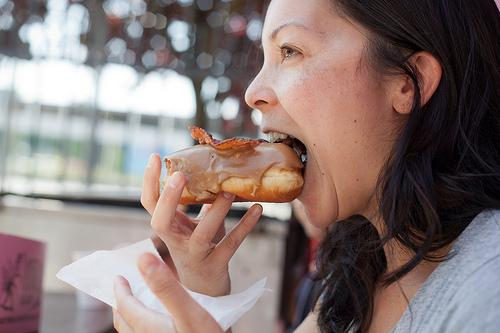List three facial features of the woman in the image. The woman has a brown left eye, a nose, and a left ear. In the image, mention an object that appears to be on a table. There is a cup on the table. Analyze the interaction between the woman and the donut in the context of the image. The woman is actively engaged in eating the donut, as she holds it to her mouth and appears to be biting it. The donut has a significant presence in the scene, with details like the brown icing and chocolate chips described. What is the woman wearing, and what is the color of her hair? The woman is wearing a gray shirt, and her hair is black. Describe the background and the setting of the scene depicted in the image. The scene is set outdoors with lights in the distance, and the background is slightly blurred. There is a purple sign on a window, and a red and black object in the background. Provide an estimation for the total number of objects mentioned in the image. There are approximately 39 different objects mentioned within the image. Assess the emotion or sentiment conveyed by the image. The image conveys a feeling of enjoyment or indulgence, as the woman is eating a designer donut. Determine the quality of the given image based on the mentioned details in the image. The image seems to be of decent quality, as the image information provides a substantial number of details about various objects and features within the scene. Identify the color of the donut's icing and the activity the woman is doing in the image. The icing on the donut is brown, and the woman is biting or eating the donut. What is the woman holding in her hand besides the donut, and what color is it? The woman is holding a white napkin in her hand. Identify the woman's eye color. Brown What color is the woman's hair? Black What is the color of the item in the background? Red and black Determine if the image is indoors or outdoors. Outdoors Categorize the woman's hair color and length. Black and long Analyze the image and create a descriptive caption. A woman with black hair eats a chocolate-covered designer donut while holding a white napkin outdoors with a red and black object in the background. Does the woman have a mole on her skin? Yes Observe the image and list any visible food items. Donut What type of object appears as purple in the image? A sign on a window What is the color of the paper in the woman's hand? White Which item is the woman consuming? A donut Identify the action being performed by the woman in the image. Eating a donut Describe the woman's attire. Gray shirt In this image, a woman is eating a specific type of designer dessert. Identify the dessert. A designer donut What is the woman's left hand holding? A napkin 